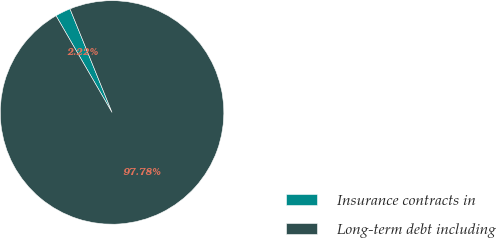<chart> <loc_0><loc_0><loc_500><loc_500><pie_chart><fcel>Insurance contracts in<fcel>Long-term debt including<nl><fcel>2.22%<fcel>97.78%<nl></chart> 